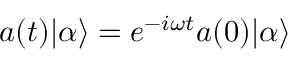<formula> <loc_0><loc_0><loc_500><loc_500>a ( t ) | \alpha \rangle = e ^ { - i \omega t } a ( 0 ) | \alpha \rangle</formula> 